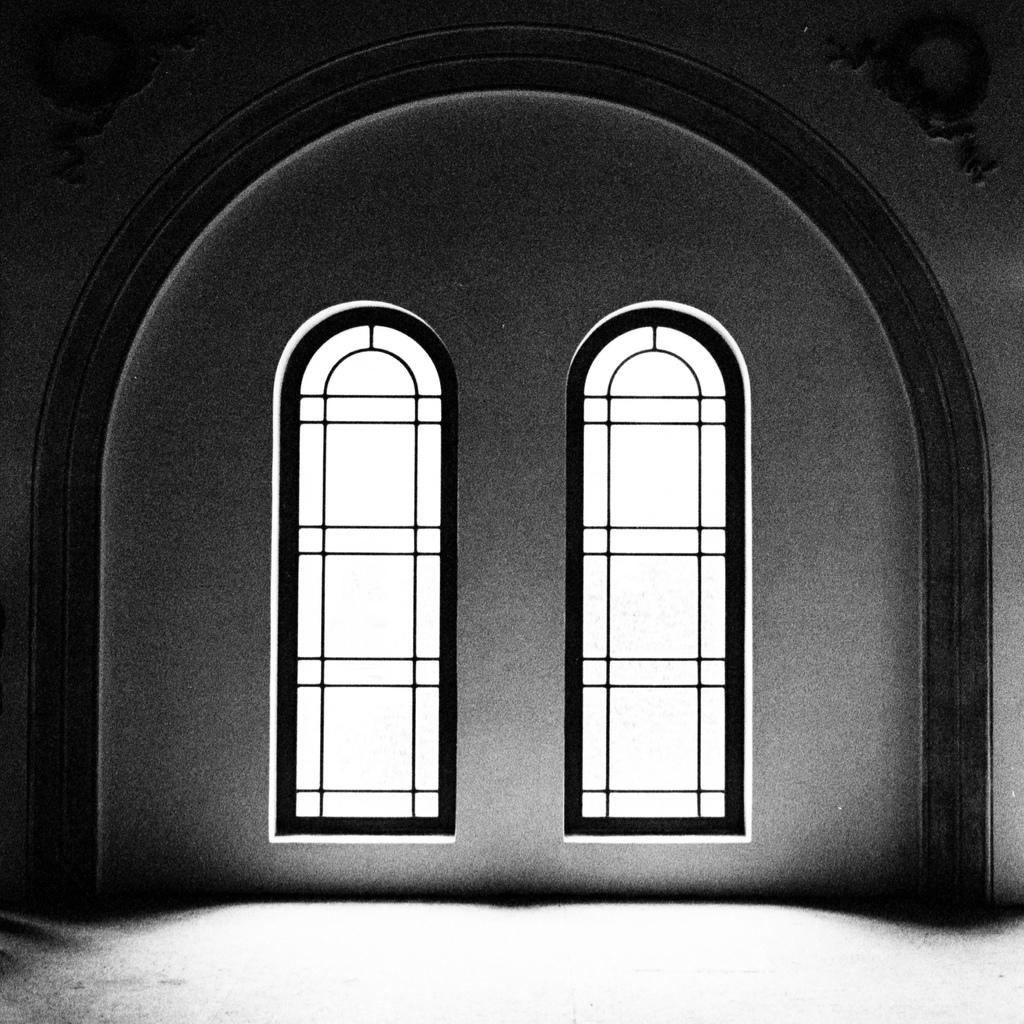Where was the image taken? The image was taken in a building. What can be seen in the center of the image? There are windows in the center of the image. What else is visible in the image? There is a wall visible in the image. What type of action are the mice taking in the image? There are no mice present in the image. What decision was made by the wall in the image? Walls do not make decisions; they are inanimate objects. 